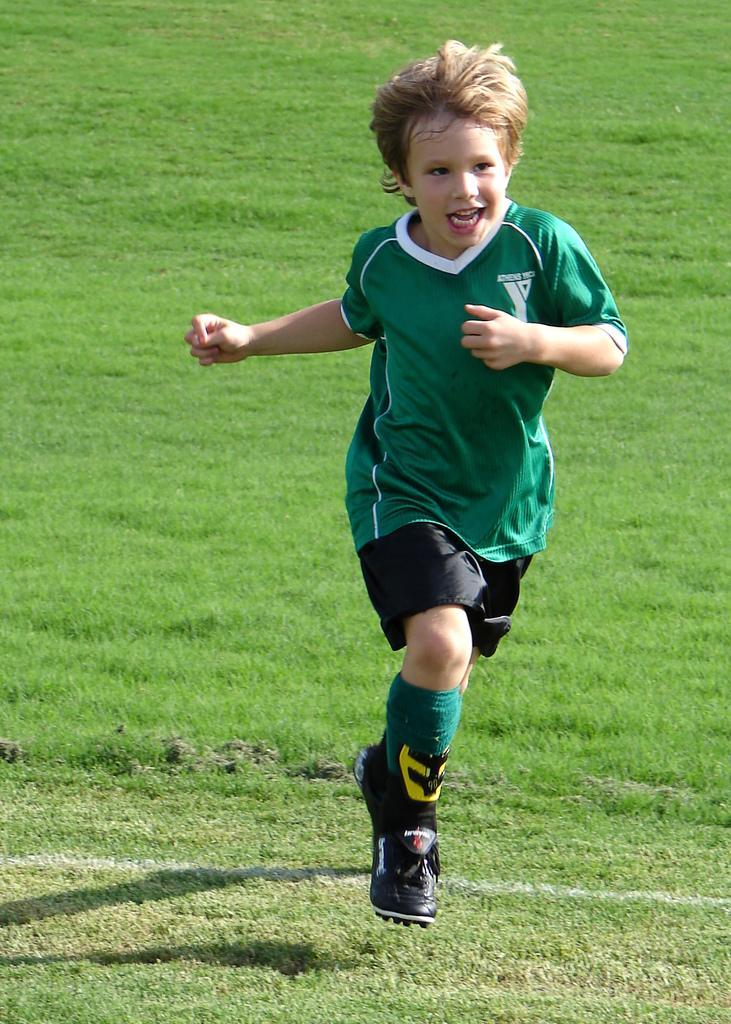Could you give a brief overview of what you see in this image? In this picture I can see there is a boy running, looking at right side and smiling. He is wearing a green jersey and a black trouser. He is also wearing shoes and there's grass on the floor. 